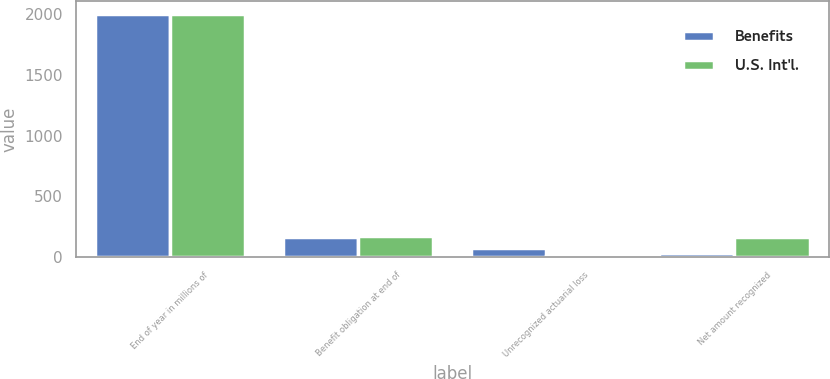Convert chart. <chart><loc_0><loc_0><loc_500><loc_500><stacked_bar_chart><ecel><fcel>End of year in millions of<fcel>Benefit obligation at end of<fcel>Unrecognized actuarial loss<fcel>Net amount recognized<nl><fcel>Benefits<fcel>2004<fcel>166<fcel>74<fcel>32<nl><fcel>U.S. Int'l.<fcel>2004<fcel>175<fcel>12<fcel>166<nl></chart> 